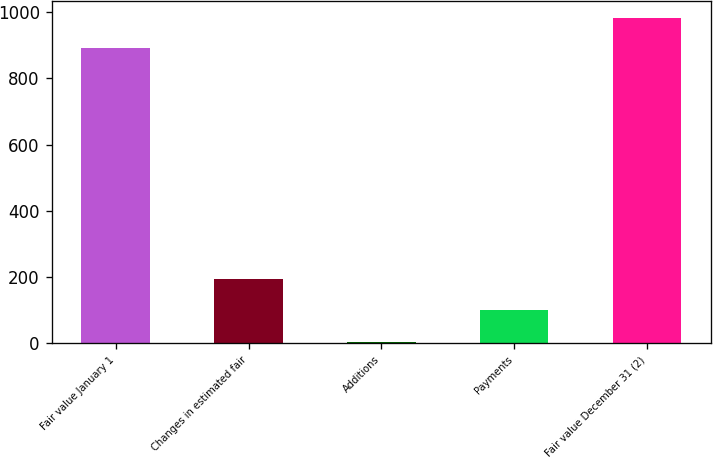Convert chart. <chart><loc_0><loc_0><loc_500><loc_500><bar_chart><fcel>Fair value January 1<fcel>Changes in estimated fair<fcel>Additions<fcel>Payments<fcel>Fair value December 31 (2)<nl><fcel>891<fcel>193.2<fcel>3<fcel>100<fcel>984.2<nl></chart> 